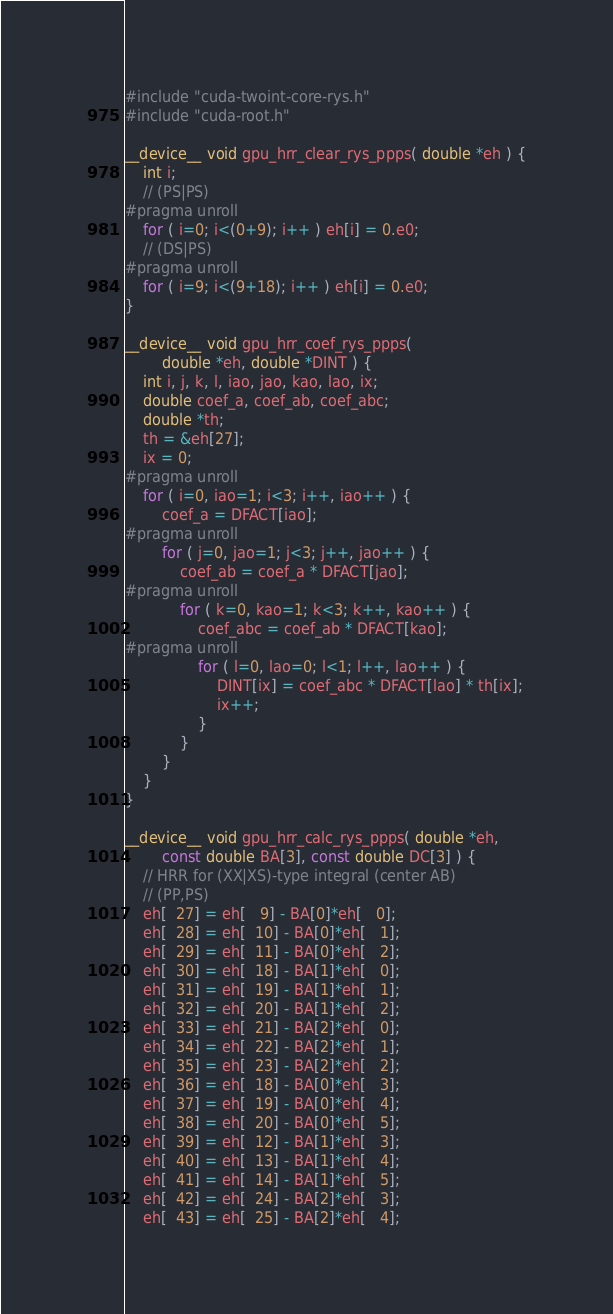Convert code to text. <code><loc_0><loc_0><loc_500><loc_500><_Cuda_>#include "cuda-twoint-core-rys.h"
#include "cuda-root.h"

__device__ void gpu_hrr_clear_rys_ppps( double *eh ) {
    int i;
    // (PS|PS)
#pragma unroll
    for ( i=0; i<(0+9); i++ ) eh[i] = 0.e0;
    // (DS|PS)
#pragma unroll
    for ( i=9; i<(9+18); i++ ) eh[i] = 0.e0;
}

__device__ void gpu_hrr_coef_rys_ppps(
        double *eh, double *DINT ) {
    int i, j, k, l, iao, jao, kao, lao, ix;
    double coef_a, coef_ab, coef_abc;
    double *th;
    th = &eh[27];
    ix = 0;
#pragma unroll
    for ( i=0, iao=1; i<3; i++, iao++ ) {
        coef_a = DFACT[iao];
#pragma unroll
        for ( j=0, jao=1; j<3; j++, jao++ ) {
            coef_ab = coef_a * DFACT[jao];
#pragma unroll
            for ( k=0, kao=1; k<3; k++, kao++ ) {
                coef_abc = coef_ab * DFACT[kao];
#pragma unroll
                for ( l=0, lao=0; l<1; l++, lao++ ) {
                    DINT[ix] = coef_abc * DFACT[lao] * th[ix];
                    ix++;
                }
            }
        }
    }
}

__device__ void gpu_hrr_calc_rys_ppps( double *eh,
        const double BA[3], const double DC[3] ) {
    // HRR for (XX|XS)-type integral (center AB)
    // (PP,PS)
    eh[  27] = eh[   9] - BA[0]*eh[   0];
    eh[  28] = eh[  10] - BA[0]*eh[   1];
    eh[  29] = eh[  11] - BA[0]*eh[   2];
    eh[  30] = eh[  18] - BA[1]*eh[   0];
    eh[  31] = eh[  19] - BA[1]*eh[   1];
    eh[  32] = eh[  20] - BA[1]*eh[   2];
    eh[  33] = eh[  21] - BA[2]*eh[   0];
    eh[  34] = eh[  22] - BA[2]*eh[   1];
    eh[  35] = eh[  23] - BA[2]*eh[   2];
    eh[  36] = eh[  18] - BA[0]*eh[   3];
    eh[  37] = eh[  19] - BA[0]*eh[   4];
    eh[  38] = eh[  20] - BA[0]*eh[   5];
    eh[  39] = eh[  12] - BA[1]*eh[   3];
    eh[  40] = eh[  13] - BA[1]*eh[   4];
    eh[  41] = eh[  14] - BA[1]*eh[   5];
    eh[  42] = eh[  24] - BA[2]*eh[   3];
    eh[  43] = eh[  25] - BA[2]*eh[   4];</code> 